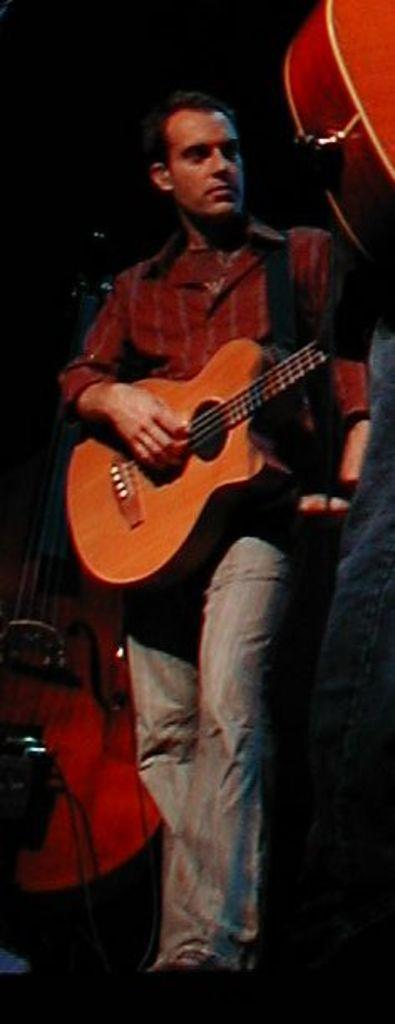Who or what is the main subject of the image? There is a person in the image. What is the person wearing? The person is wearing a red shirt. What activity is the person engaged in? The person is playing a guitar. How many zippers can be seen on the person's shirt in the image? There are no zippers visible on the person's shirt in the image. What type of houses are present in the image? There are no houses present in the image; it features a person playing a guitar. 